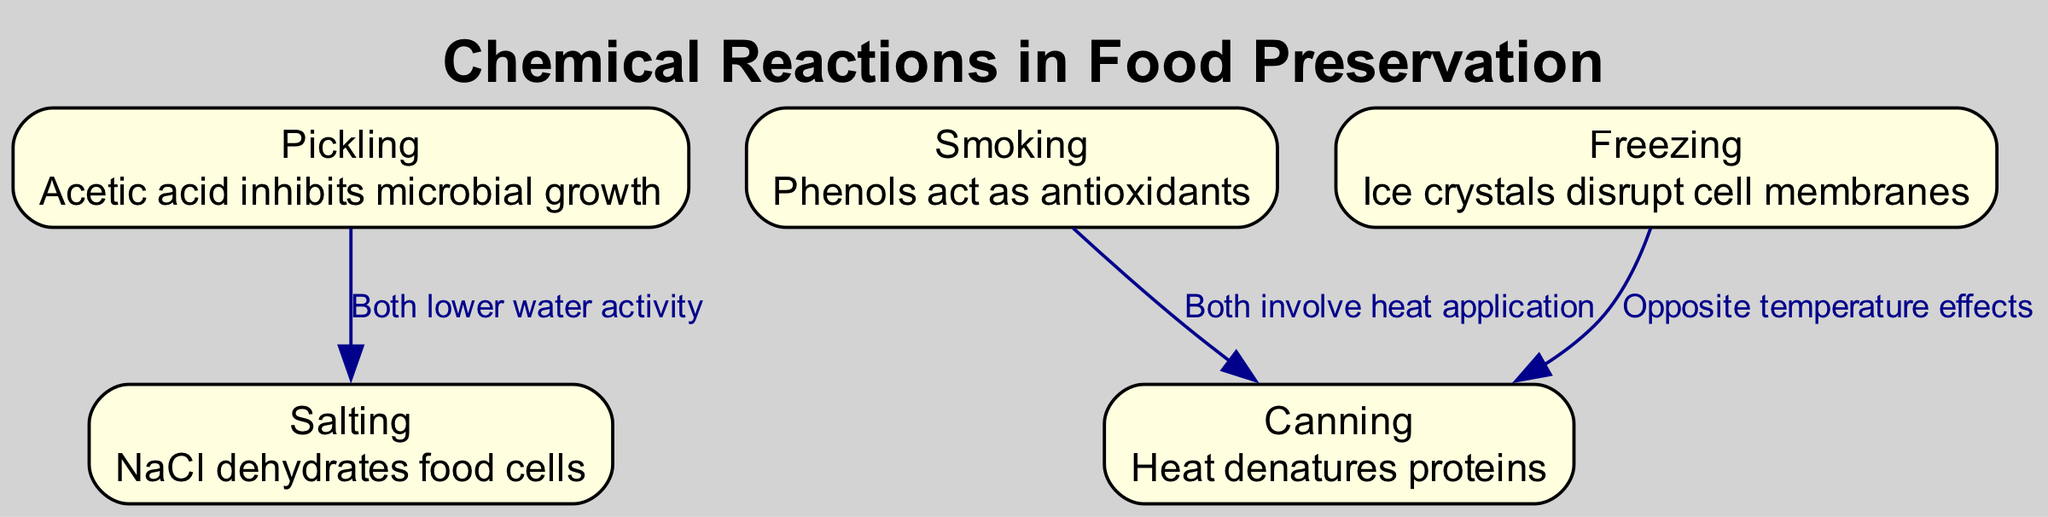What food preservation technique involves acetic acid? The diagram indicates that the food preservation technique involving acetic acid is Pickling, as described in the first node.
Answer: Pickling What description is associated with Salting? Referring to the second node, the description associated with Salting is that "NaCl dehydrates food cells".
Answer: NaCl dehydrates food cells How many preservation techniques are illustrated in the diagram? The diagram includes five unique preservation techniques, represented through five nodes. The count of nodes gives the total number of techniques depicted.
Answer: Five What do Pickling and Salting have in common? The diagram shows an edge connecting Pickling and Salting, labeled "Both lower water activity", indicating the commonality between these two techniques.
Answer: Both lower water activity Which two food preservation methods involve heat application? According to the diagram, there is a direct relationship indicated by an edge connecting Smoking and Canning, stating that they "Both involve heat application". This confirms that both methods share this characteristic.
Answer: Smoking and Canning What happens to proteins during the Canning process? The description for Canning in the fifth node states that "Heat denatures proteins", which explains the effect of heat during this preservation process.
Answer: Heat denatures proteins What are the opposite effects observed in Freezing and Canning? The edge connecting Freezing and Canning states "Opposite temperature effects", which describes how these two techniques impact food preservation differently based on temperature variations.
Answer: Opposite temperature effects Which preservation technique acts as an antioxidant? The third node specifies that Smoking involves phenols, which act as antioxidants, identifying this preservation technique's functional role with respect to food safety.
Answer: Smoking How does Freezing affect cell membranes? The diagram describes the effect of Freezing, stating "Ice crystals disrupt cell membranes", clarifying its impact on food structure during preservation.
Answer: Ice crystals disrupt cell membranes 